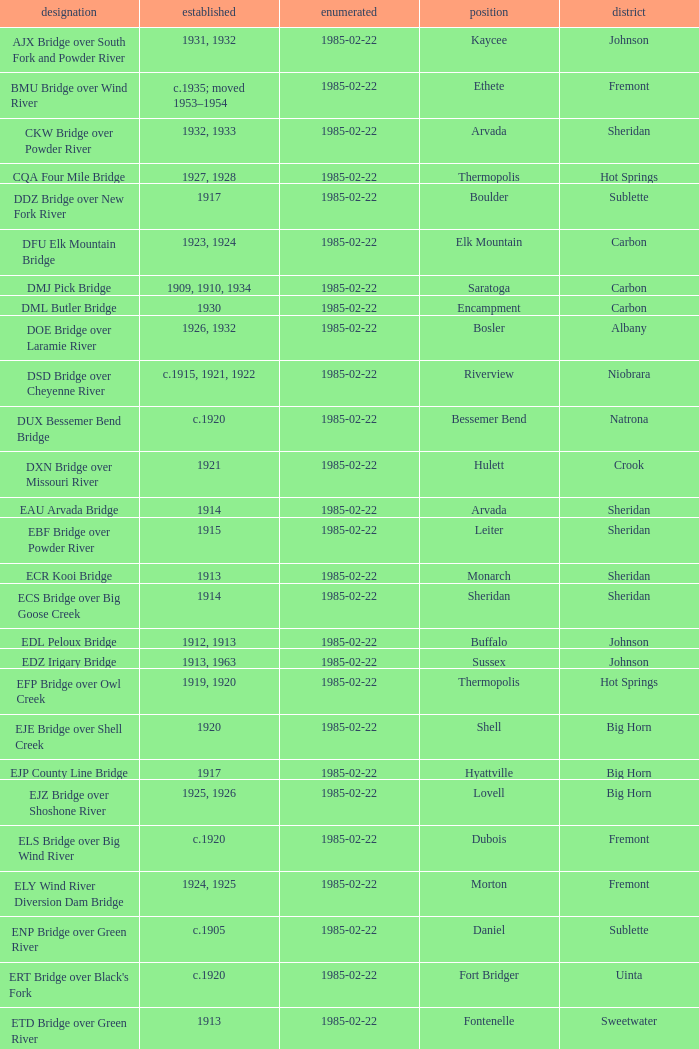What is the listed for the bridge at Daniel in Sublette county? 1985-02-22. 